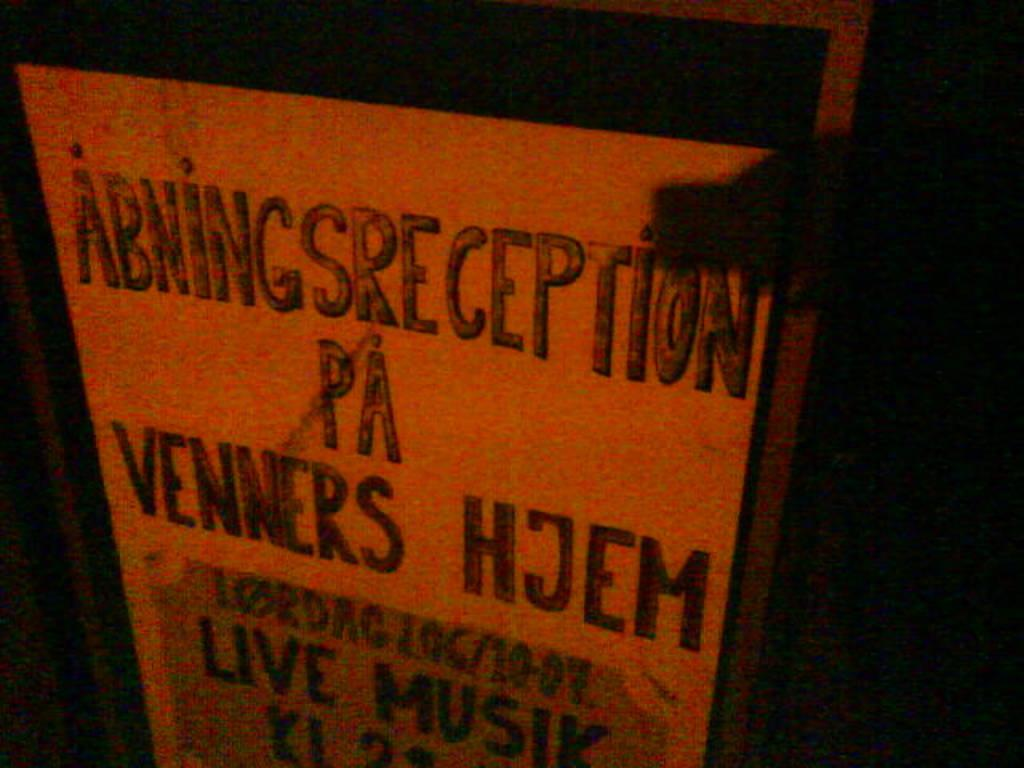<image>
Relay a brief, clear account of the picture shown. A signboard advertising the Abnings reception featuring live musik. 